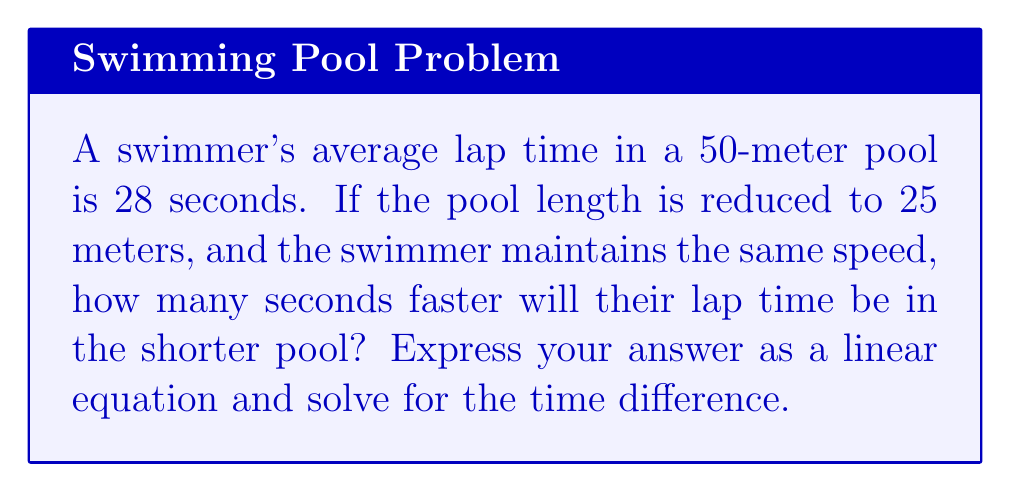Teach me how to tackle this problem. Let's approach this step-by-step:

1) First, we need to set up variables:
   Let $t$ be the time in seconds for the 25-meter pool
   Let $x$ be the difference in seconds between the 50-meter and 25-meter lap times

2) We know that speed is distance divided by time. In both cases, the speed is the same:

   For 50-meter pool: $\frac{50}{28} = \text{speed}$
   For 25-meter pool: $\frac{25}{t} = \text{speed}$

3) Since these are equal, we can set up an equation:

   $$\frac{50}{28} = \frac{25}{t}$$

4) Cross multiply:

   $$50t = 28 \cdot 25$$

5) Simplify:

   $$50t = 700$$

6) Solve for $t$:

   $$t = \frac{700}{50} = 14$$

7) Now, we can set up our linear equation for the time difference:

   $$x = 28 - t$$

8) Substitute the value of $t$:

   $$x = 28 - 14 = 14$$

Therefore, the linear equation is $x = 28 - t$, and solving it gives us $x = 14$.
Answer: $x = 28 - t$; 14 seconds 